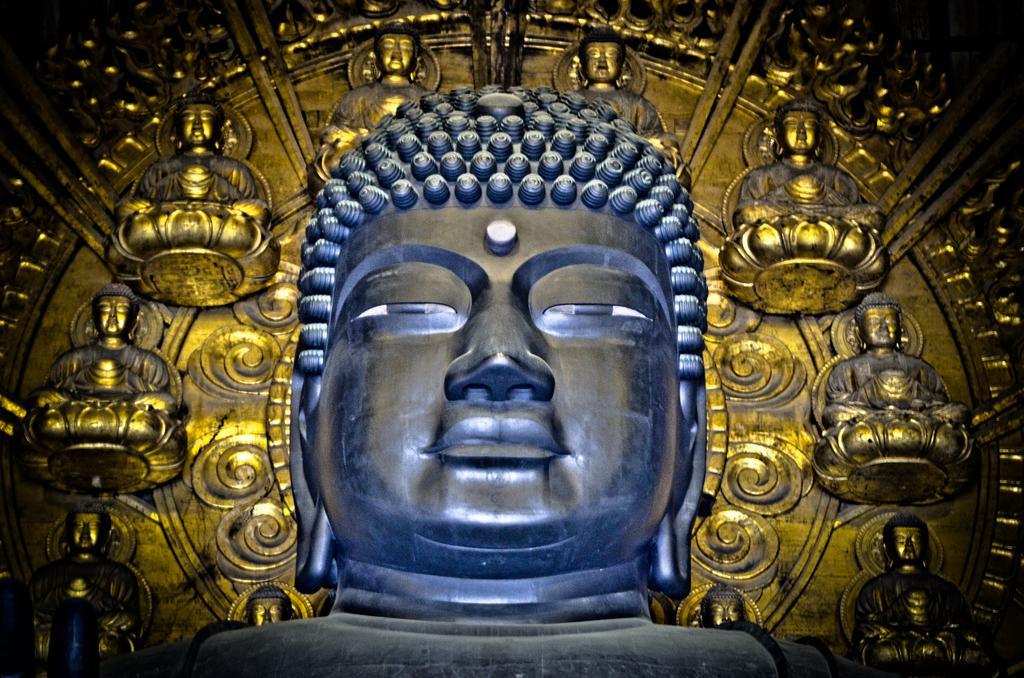Can you describe this image briefly? In this picture we can see a sculpture. In the background we can see the carvings on the metal. 